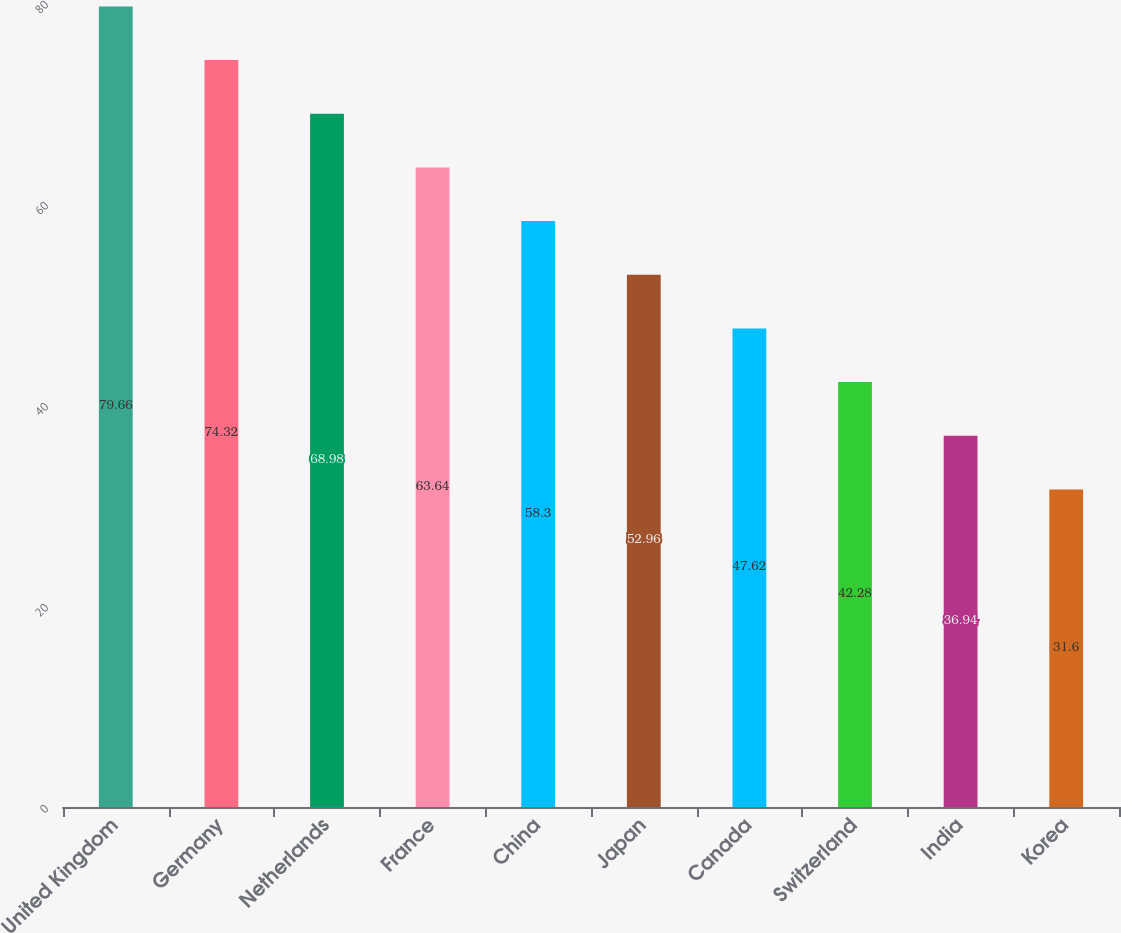Convert chart to OTSL. <chart><loc_0><loc_0><loc_500><loc_500><bar_chart><fcel>United Kingdom<fcel>Germany<fcel>Netherlands<fcel>France<fcel>China<fcel>Japan<fcel>Canada<fcel>Switzerland<fcel>India<fcel>Korea<nl><fcel>79.66<fcel>74.32<fcel>68.98<fcel>63.64<fcel>58.3<fcel>52.96<fcel>47.62<fcel>42.28<fcel>36.94<fcel>31.6<nl></chart> 